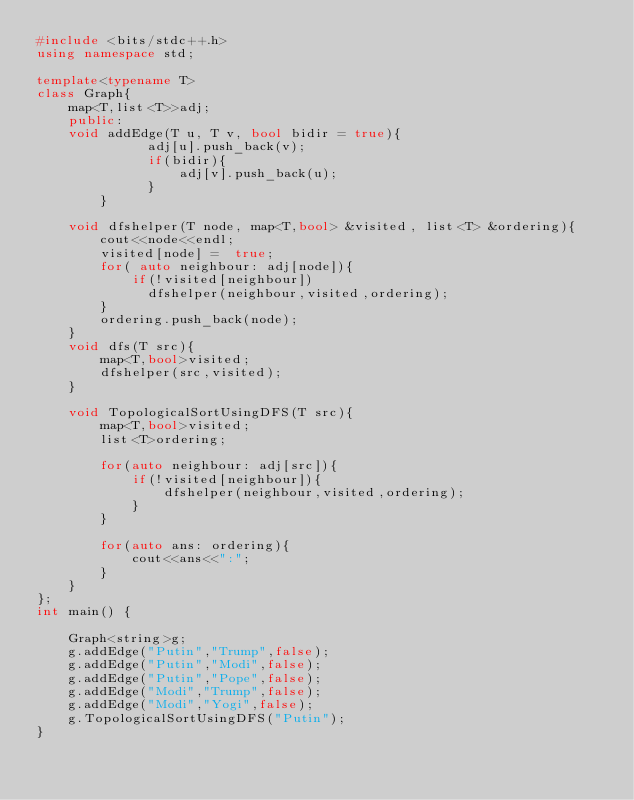Convert code to text. <code><loc_0><loc_0><loc_500><loc_500><_C++_>#include <bits/stdc++.h>
using namespace std;

template<typename T>
class Graph{
    map<T,list<T>>adj;
    public:
    void addEdge(T u, T v, bool bidir = true){
              adj[u].push_back(v);
              if(bidir){
                  adj[v].push_back(u);
              }
        }

    void dfshelper(T node, map<T,bool> &visited, list<T> &ordering){
        cout<<node<<endl;
        visited[node] =  true;
        for( auto neighbour: adj[node]){
            if(!visited[neighbour])
              dfshelper(neighbour,visited,ordering);
        }
        ordering.push_back(node);
    }
    void dfs(T src){
        map<T,bool>visited;
        dfshelper(src,visited);
    }

    void TopologicalSortUsingDFS(T src){
        map<T,bool>visited;
        list<T>ordering;

        for(auto neighbour: adj[src]){
            if(!visited[neighbour]){
                dfshelper(neighbour,visited,ordering);
            }
        }
        
        for(auto ans: ordering){
            cout<<ans<<":"; 
        }
    }
};
int main() {
    
    Graph<string>g;
    g.addEdge("Putin","Trump",false);
    g.addEdge("Putin","Modi",false);
    g.addEdge("Putin","Pope",false);
    g.addEdge("Modi","Trump",false);
    g.addEdge("Modi","Yogi",false);
    g.TopologicalSortUsingDFS("Putin");
}
</code> 